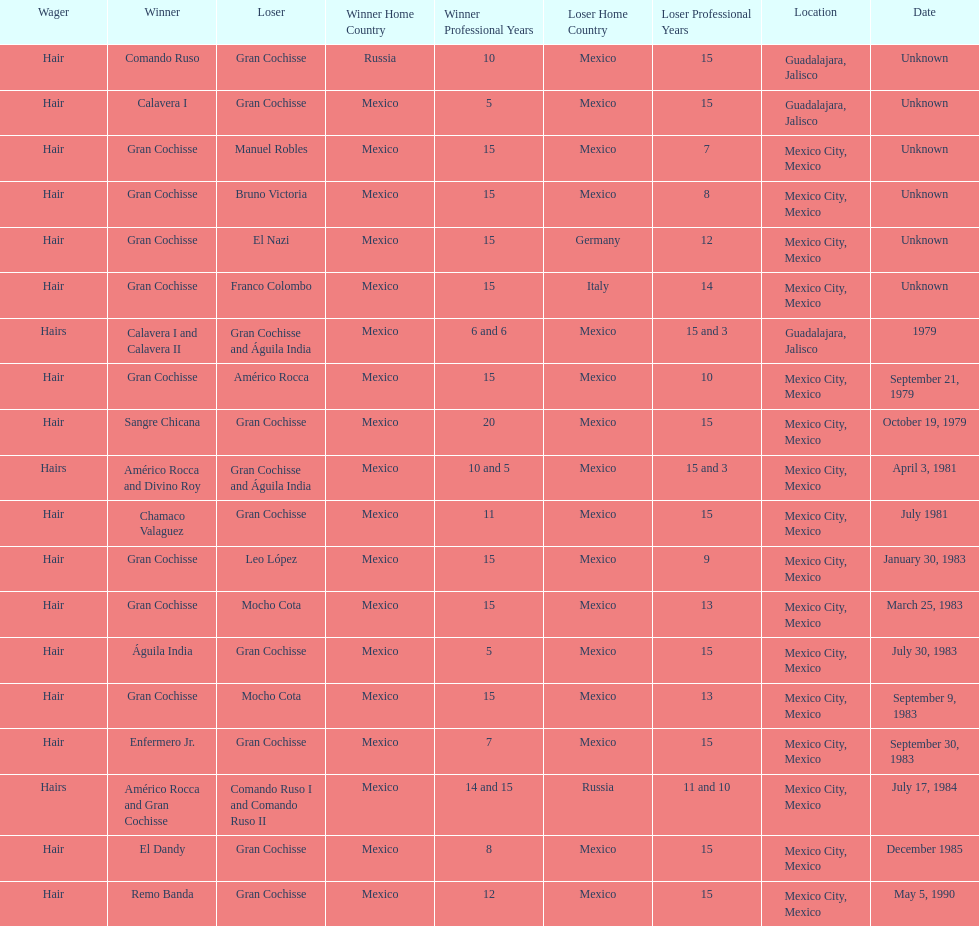When was gran chochisse first match that had a full date on record? September 21, 1979. 